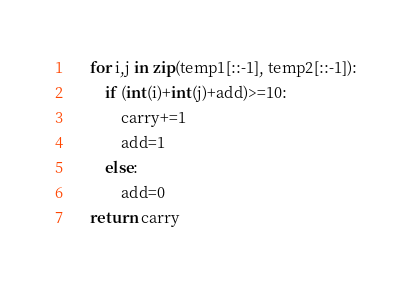Convert code to text. <code><loc_0><loc_0><loc_500><loc_500><_Python_>    for i,j in zip(temp1[::-1], temp2[::-1]):
        if (int(i)+int(j)+add)>=10:
            carry+=1
            add=1
        else:
            add=0
    return carry</code> 